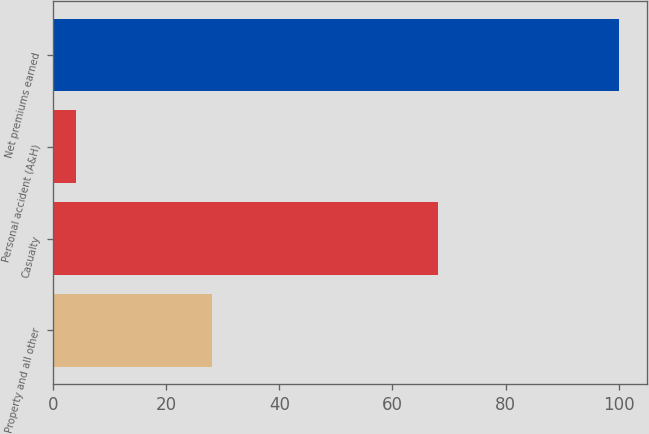<chart> <loc_0><loc_0><loc_500><loc_500><bar_chart><fcel>Property and all other<fcel>Casualty<fcel>Personal accident (A&H)<fcel>Net premiums earned<nl><fcel>28<fcel>68<fcel>4<fcel>100<nl></chart> 